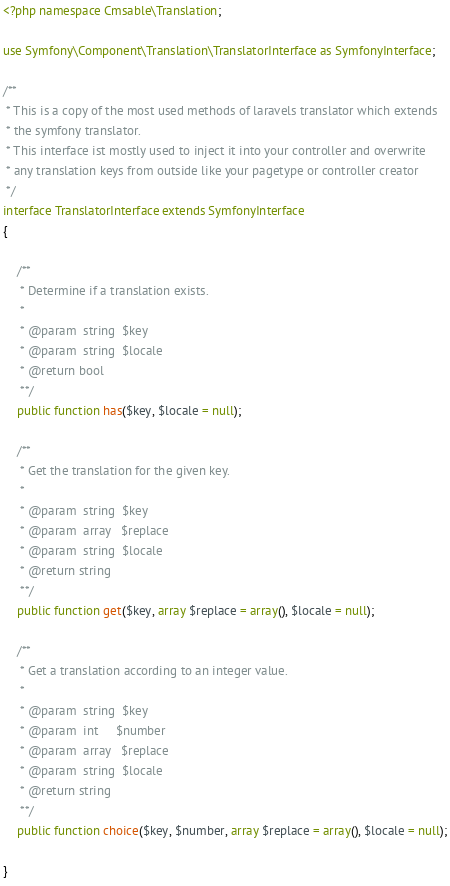<code> <loc_0><loc_0><loc_500><loc_500><_PHP_><?php namespace Cmsable\Translation;

use Symfony\Component\Translation\TranslatorInterface as SymfonyInterface;

/**
 * This is a copy of the most used methods of laravels translator which extends
 * the symfony translator.
 * This interface ist mostly used to inject it into your controller and overwrite
 * any translation keys from outside like your pagetype or controller creator
 */
interface TranslatorInterface extends SymfonyInterface
{

    /**
     * Determine if a translation exists.
     *
     * @param  string  $key
     * @param  string  $locale
     * @return bool
     **/
    public function has($key, $locale = null);

    /**
     * Get the translation for the given key.
     *
     * @param  string  $key
     * @param  array   $replace
     * @param  string  $locale
     * @return string
     **/
    public function get($key, array $replace = array(), $locale = null);

    /**
     * Get a translation according to an integer value.
     *
     * @param  string  $key
     * @param  int     $number
     * @param  array   $replace
     * @param  string  $locale
     * @return string
     **/
    public function choice($key, $number, array $replace = array(), $locale = null);

}</code> 